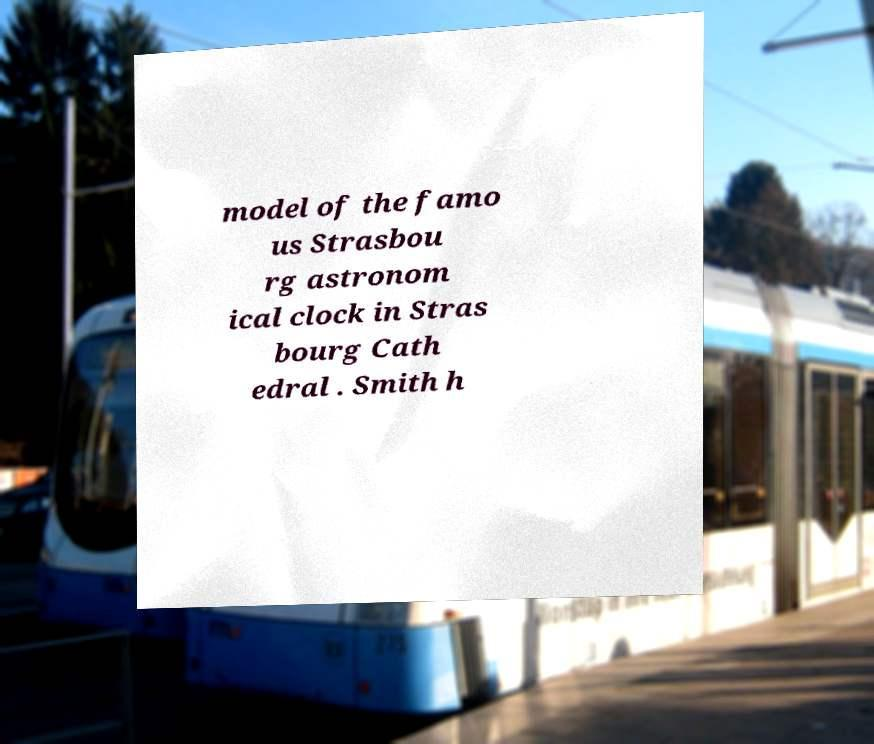Could you assist in decoding the text presented in this image and type it out clearly? model of the famo us Strasbou rg astronom ical clock in Stras bourg Cath edral . Smith h 